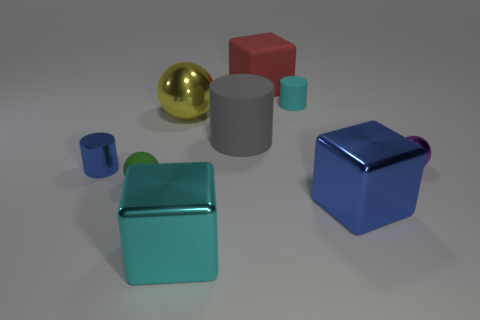Add 1 large red things. How many objects exist? 10 Subtract all balls. How many objects are left? 6 Subtract all big green spheres. Subtract all blue metallic cylinders. How many objects are left? 8 Add 4 tiny blue cylinders. How many tiny blue cylinders are left? 5 Add 1 red rubber blocks. How many red rubber blocks exist? 2 Subtract 1 blue blocks. How many objects are left? 8 